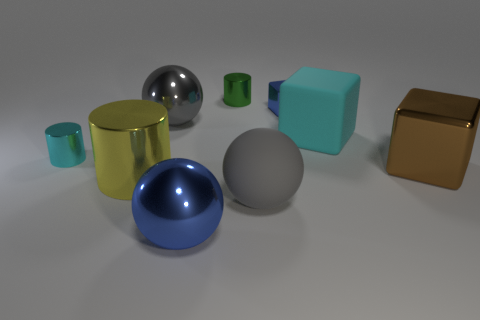Can you describe the texture of the objects? Certainly. The image shows various objects with differing textures. The rubber blocks seem to have a matte surface with a soft appearance, while the metallic sphere and cube provide a reflection of their surroundings, indicating a smooth and shiny texture. The porcelain spheres reflect light softly, suggesting a smooth but non-reflective texture. 